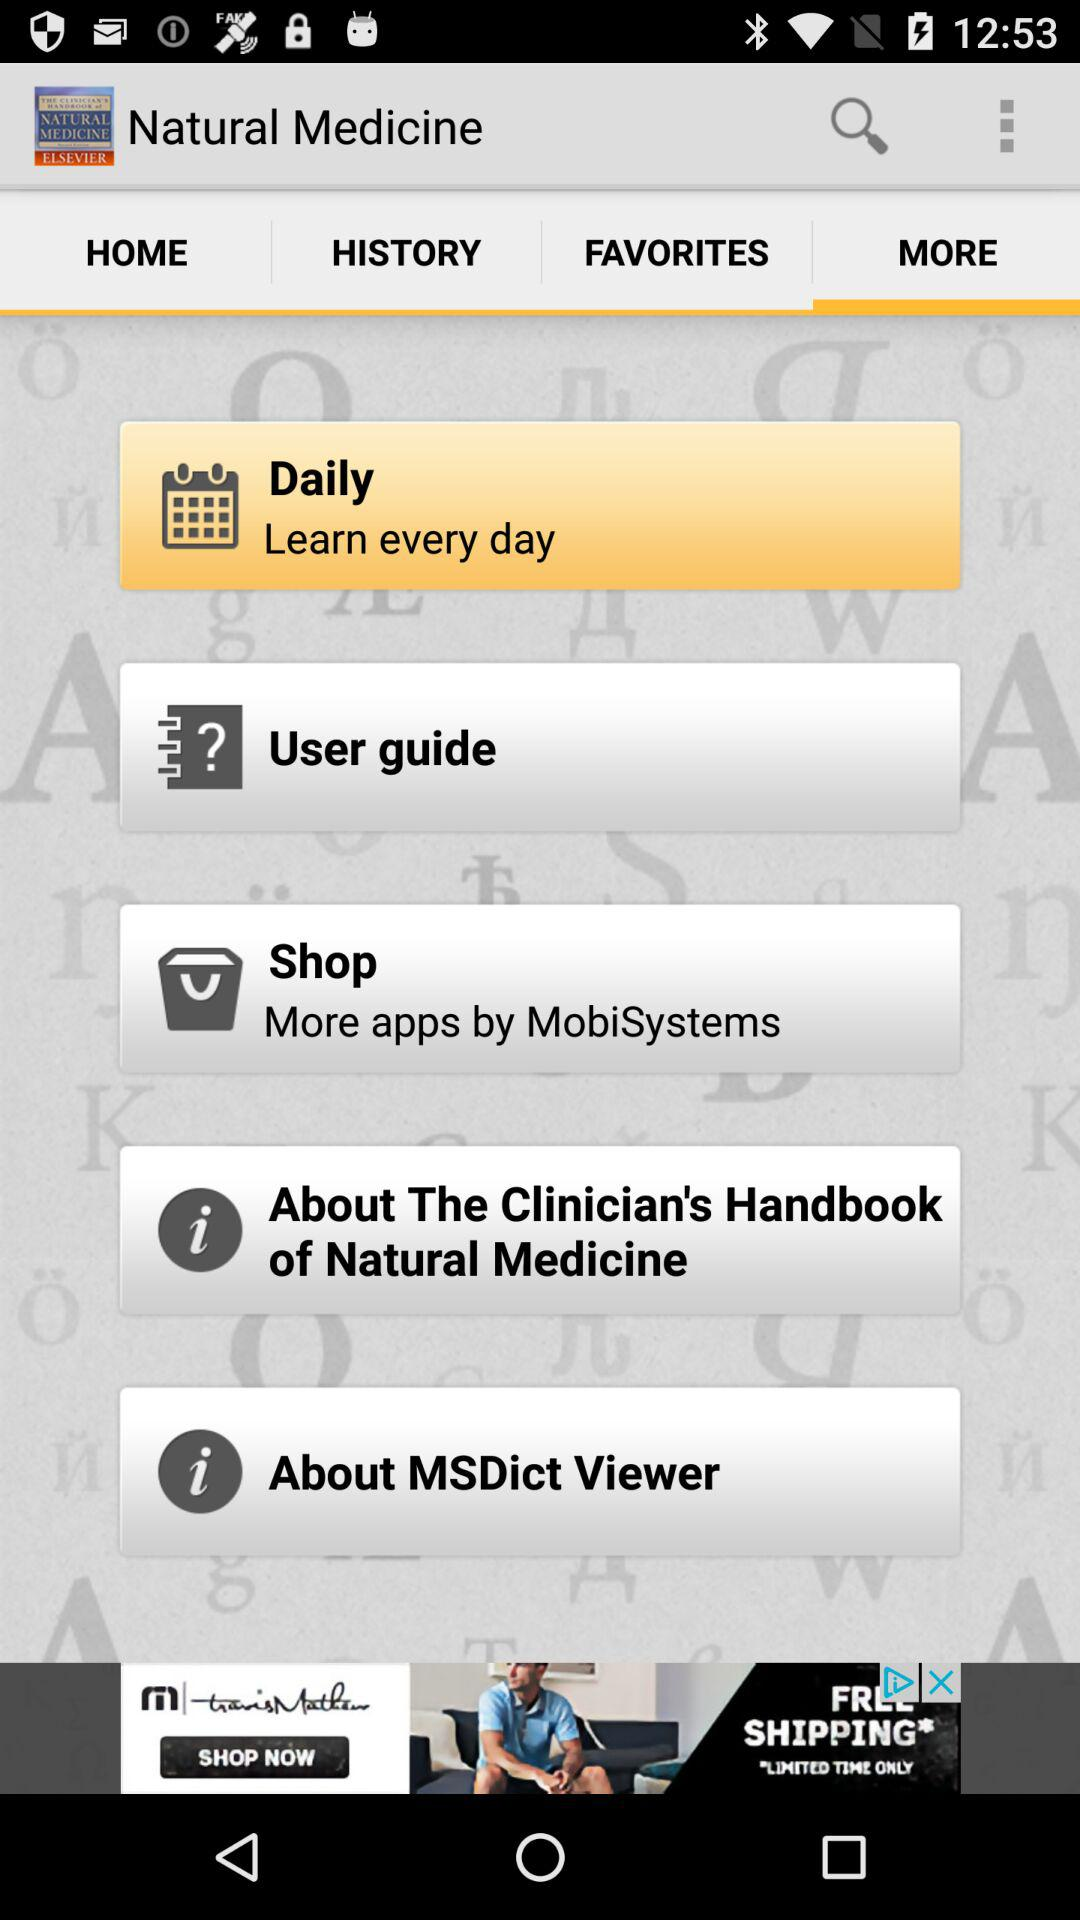Which tab is selected? The selected tab is "MORE". 